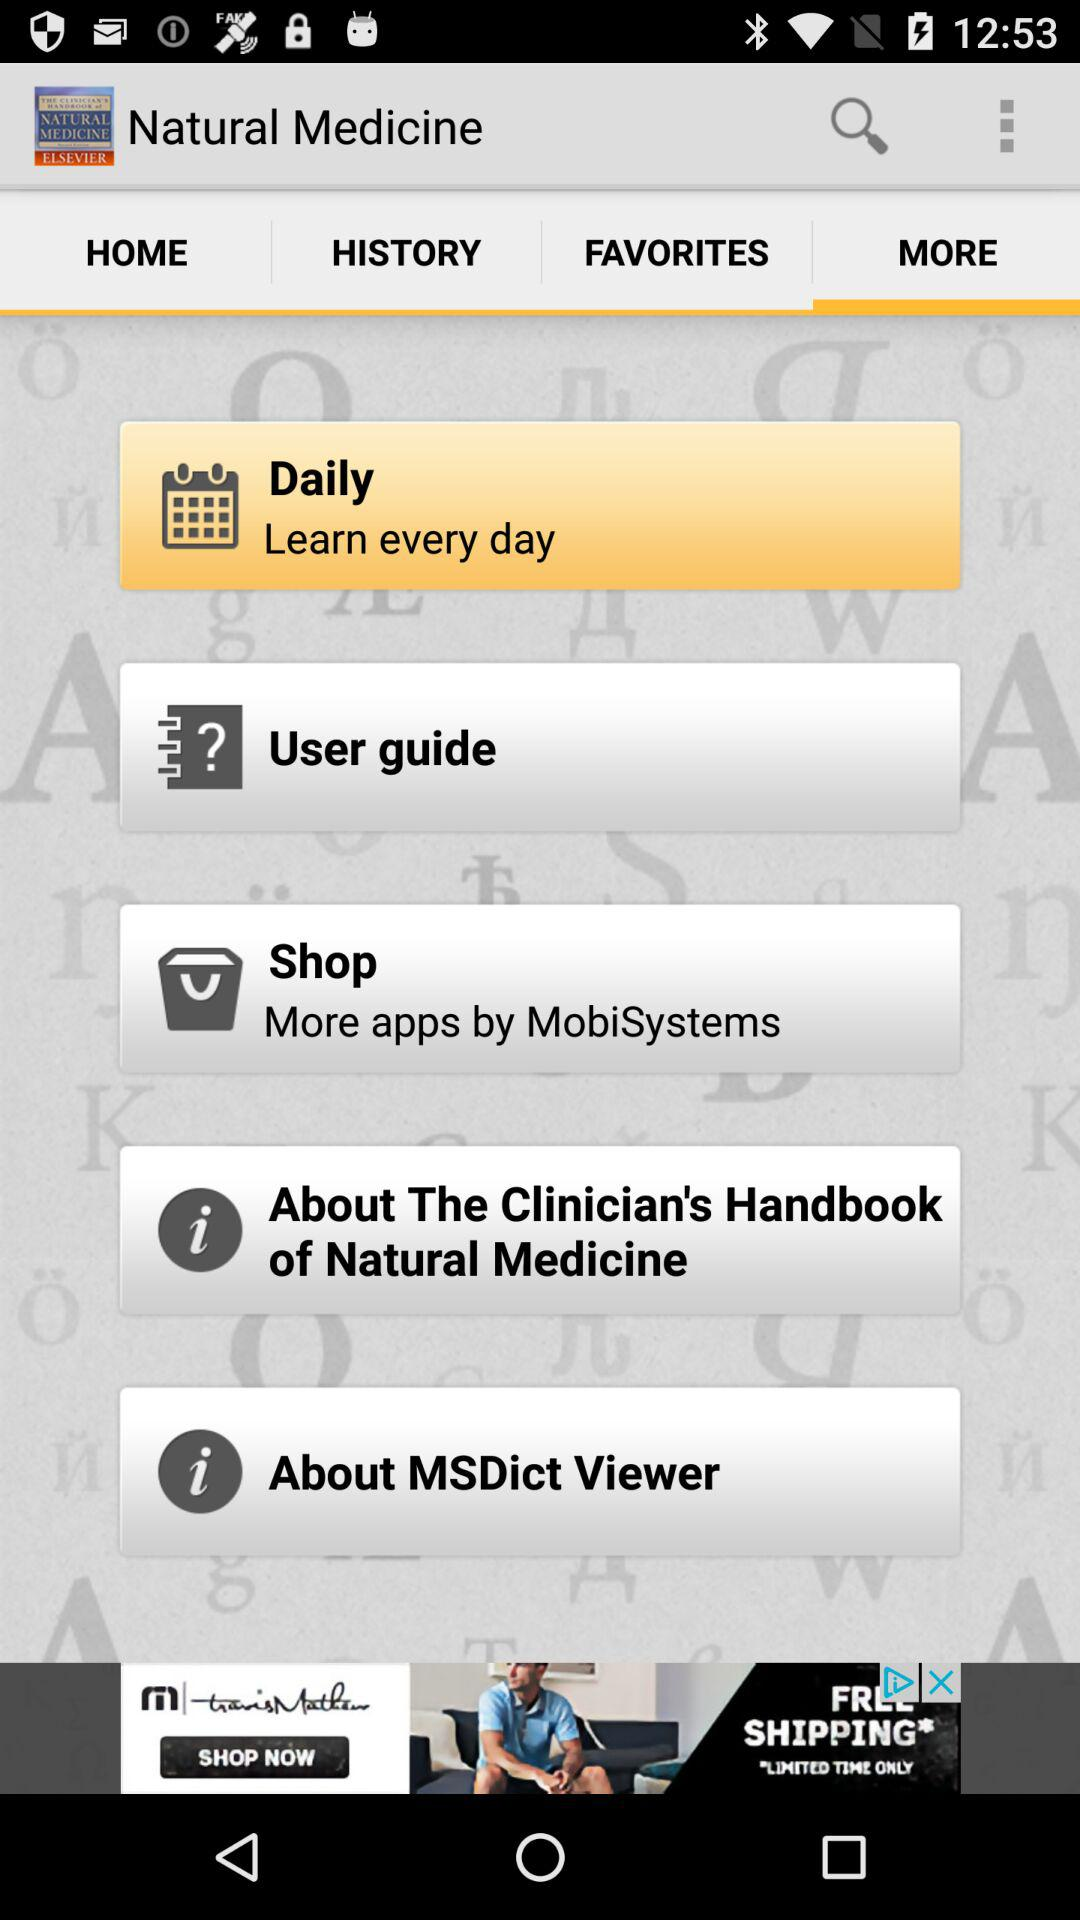Which tab is selected? The selected tab is "MORE". 